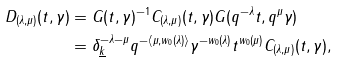<formula> <loc_0><loc_0><loc_500><loc_500>D _ { ( \lambda , \mu ) } ( t , \gamma ) & = G ( t , \gamma ) ^ { - 1 } C _ { ( \lambda , \mu ) } ( t , \gamma ) G ( q ^ { - \lambda } t , q ^ { \mu } \gamma ) \\ & = \delta _ { \underline { k } } ^ { - \lambda - \mu } q ^ { - \langle \mu , w _ { 0 } ( \lambda ) \rangle } \gamma ^ { - w _ { 0 } ( \lambda ) } t ^ { w _ { 0 } ( \mu ) } C _ { ( \lambda , \mu ) } ( t , \gamma ) ,</formula> 